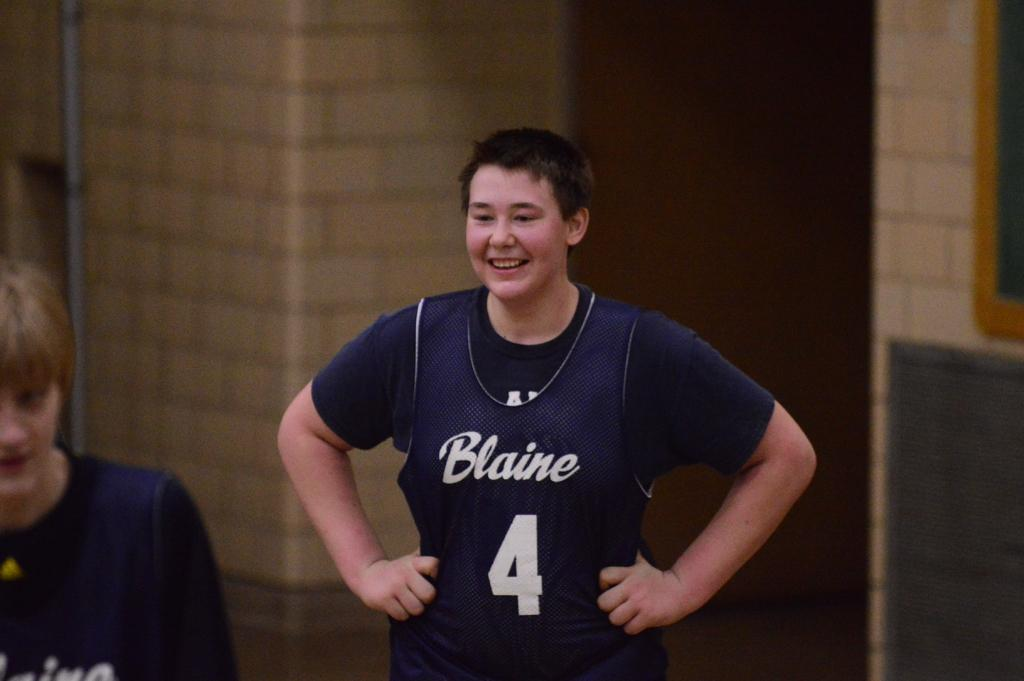<image>
Provide a brief description of the given image. Blaine sports player number 4 grins at his fellow players. 